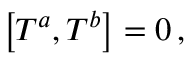<formula> <loc_0><loc_0><loc_500><loc_500>\left [ T ^ { a } , T ^ { b } \right ] = 0 \, ,</formula> 